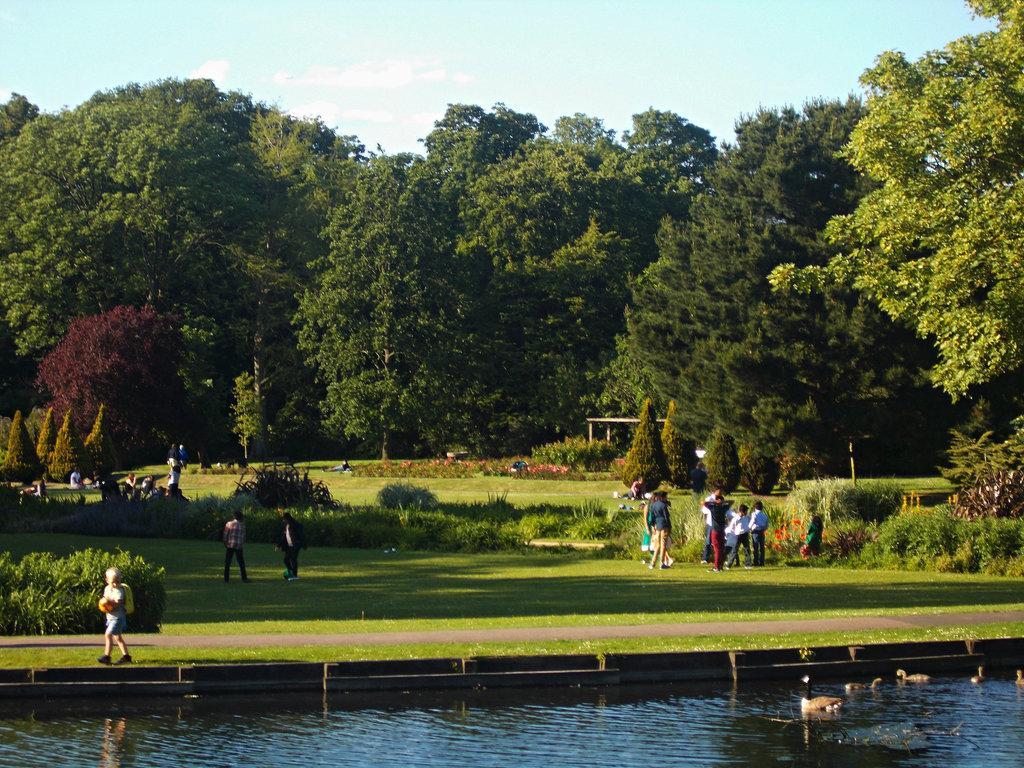How many people are in the image? There are people in the image, but the exact number is not specified. What type of natural environment is depicted in the image? The image features grass, plants, trees, and water, indicating a natural setting. What is visible in the sky in the image? The sky is visible in the image, but no specific details about the sky are provided. What type of animals can be seen in the image? There are ducks in the image. What type of can is being used to collect water in the image? There is no can or water collection system present in the image. The image features water, but it is not mentioned that they are being used to describe the image. 